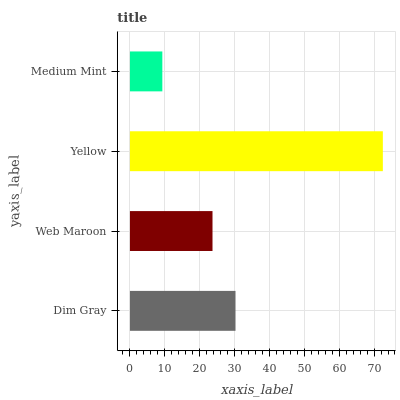Is Medium Mint the minimum?
Answer yes or no. Yes. Is Yellow the maximum?
Answer yes or no. Yes. Is Web Maroon the minimum?
Answer yes or no. No. Is Web Maroon the maximum?
Answer yes or no. No. Is Dim Gray greater than Web Maroon?
Answer yes or no. Yes. Is Web Maroon less than Dim Gray?
Answer yes or no. Yes. Is Web Maroon greater than Dim Gray?
Answer yes or no. No. Is Dim Gray less than Web Maroon?
Answer yes or no. No. Is Dim Gray the high median?
Answer yes or no. Yes. Is Web Maroon the low median?
Answer yes or no. Yes. Is Web Maroon the high median?
Answer yes or no. No. Is Yellow the low median?
Answer yes or no. No. 